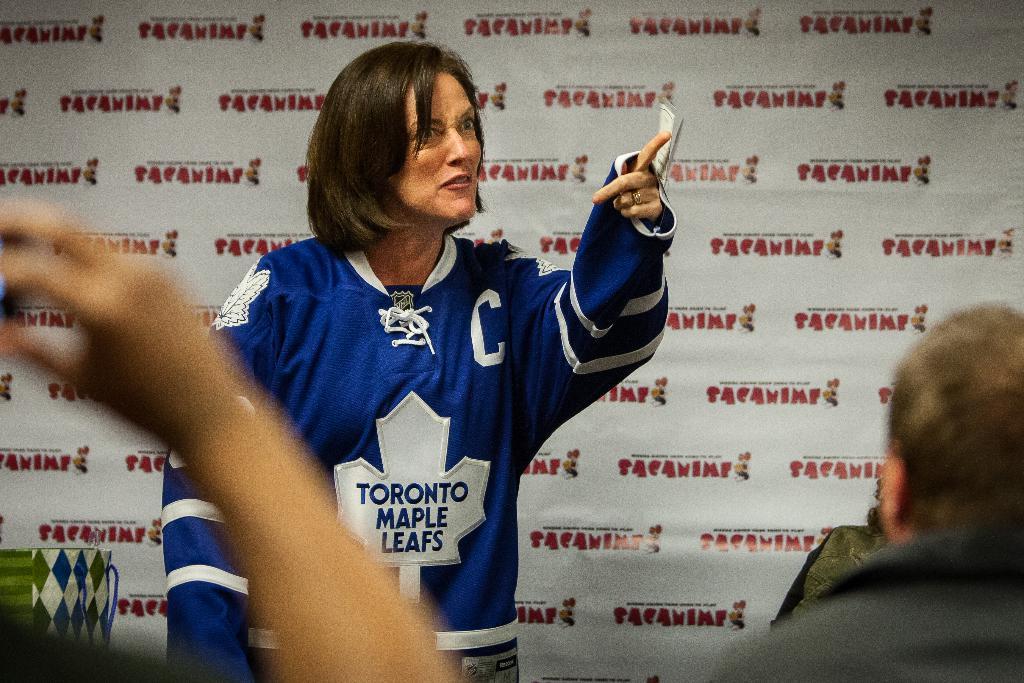What large letter is on the chest of the woman?
Your answer should be very brief. C. 